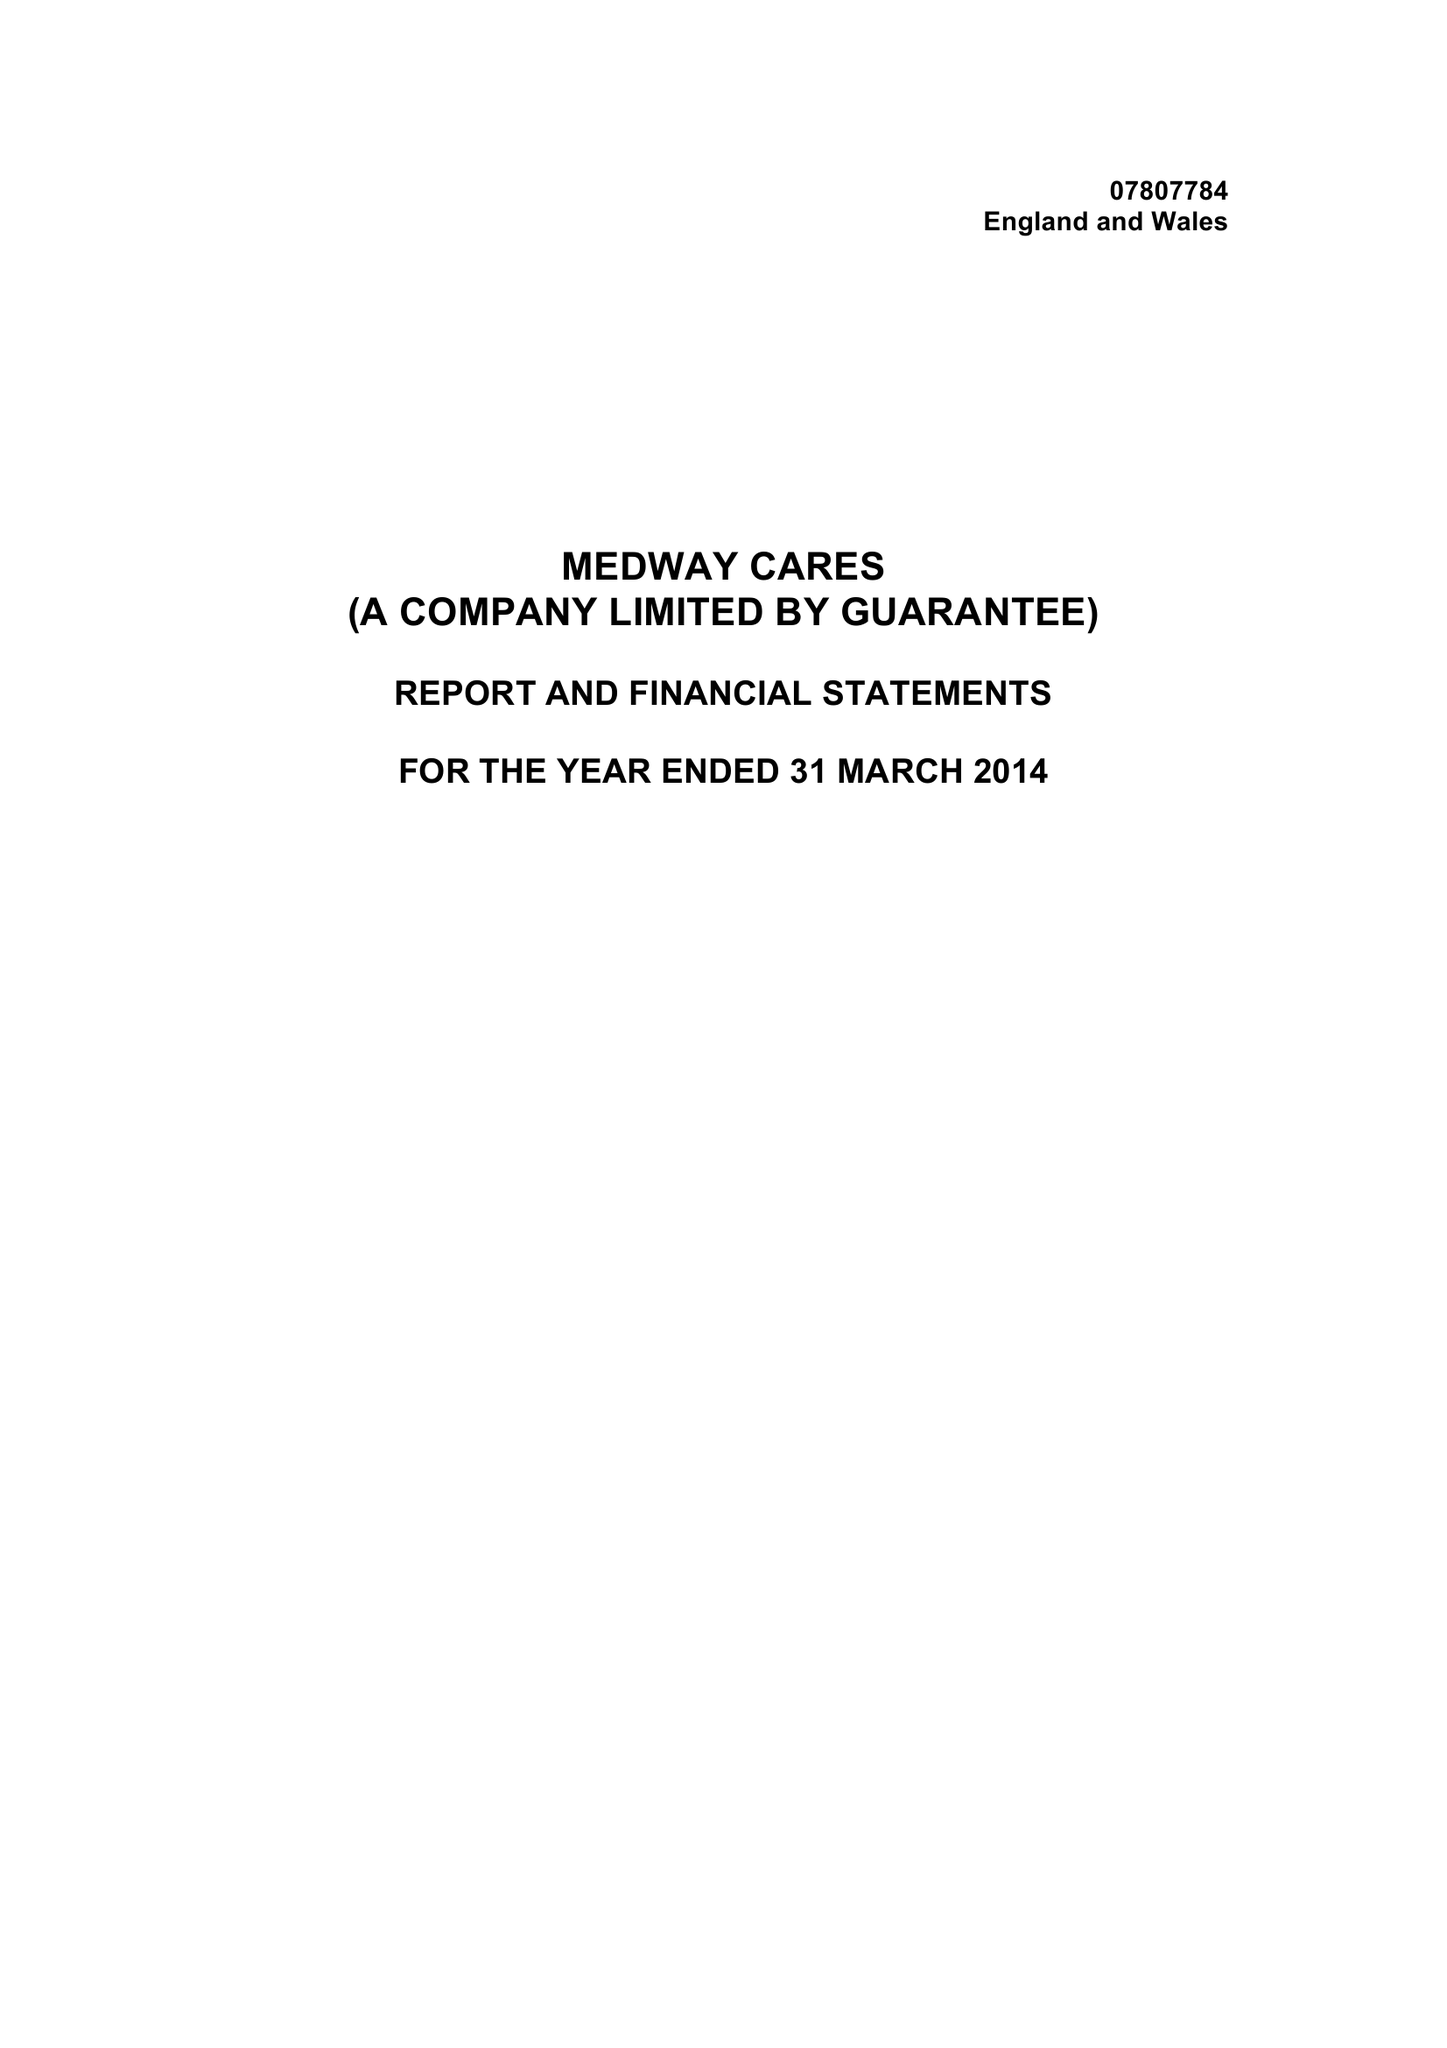What is the value for the charity_number?
Answer the question using a single word or phrase. 1145540 